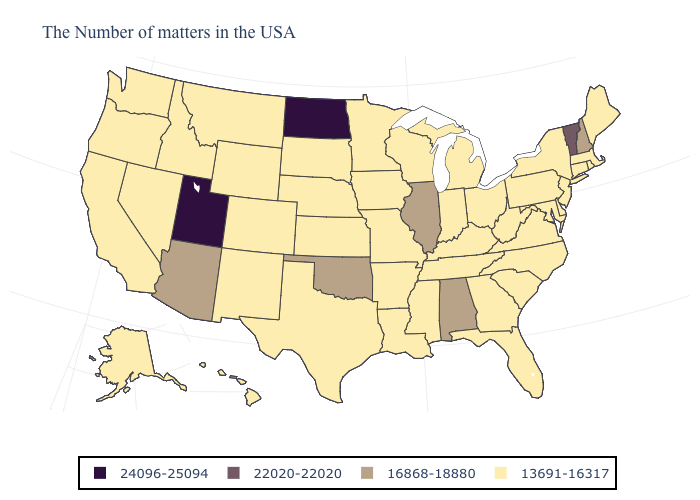Does Virginia have the same value as South Carolina?
Quick response, please. Yes. Name the states that have a value in the range 24096-25094?
Answer briefly. North Dakota, Utah. What is the lowest value in the USA?
Quick response, please. 13691-16317. What is the highest value in states that border Colorado?
Give a very brief answer. 24096-25094. How many symbols are there in the legend?
Concise answer only. 4. Among the states that border Delaware , which have the highest value?
Give a very brief answer. New Jersey, Maryland, Pennsylvania. Name the states that have a value in the range 16868-18880?
Write a very short answer. New Hampshire, Alabama, Illinois, Oklahoma, Arizona. What is the value of Michigan?
Answer briefly. 13691-16317. Does North Dakota have the highest value in the USA?
Short answer required. Yes. Does Alaska have a higher value than Indiana?
Short answer required. No. Name the states that have a value in the range 16868-18880?
Quick response, please. New Hampshire, Alabama, Illinois, Oklahoma, Arizona. Does North Dakota have the lowest value in the MidWest?
Concise answer only. No. What is the value of Louisiana?
Short answer required. 13691-16317. 